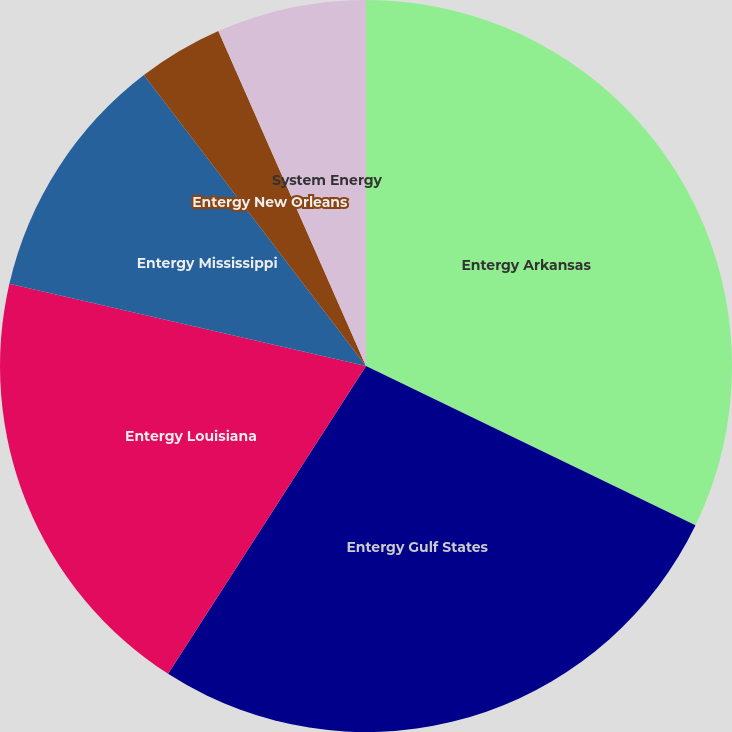Convert chart. <chart><loc_0><loc_0><loc_500><loc_500><pie_chart><fcel>Entergy Arkansas<fcel>Entergy Gulf States<fcel>Entergy Louisiana<fcel>Entergy Mississippi<fcel>Entergy New Orleans<fcel>System Energy<nl><fcel>32.17%<fcel>26.93%<fcel>19.52%<fcel>11.01%<fcel>3.77%<fcel>6.61%<nl></chart> 